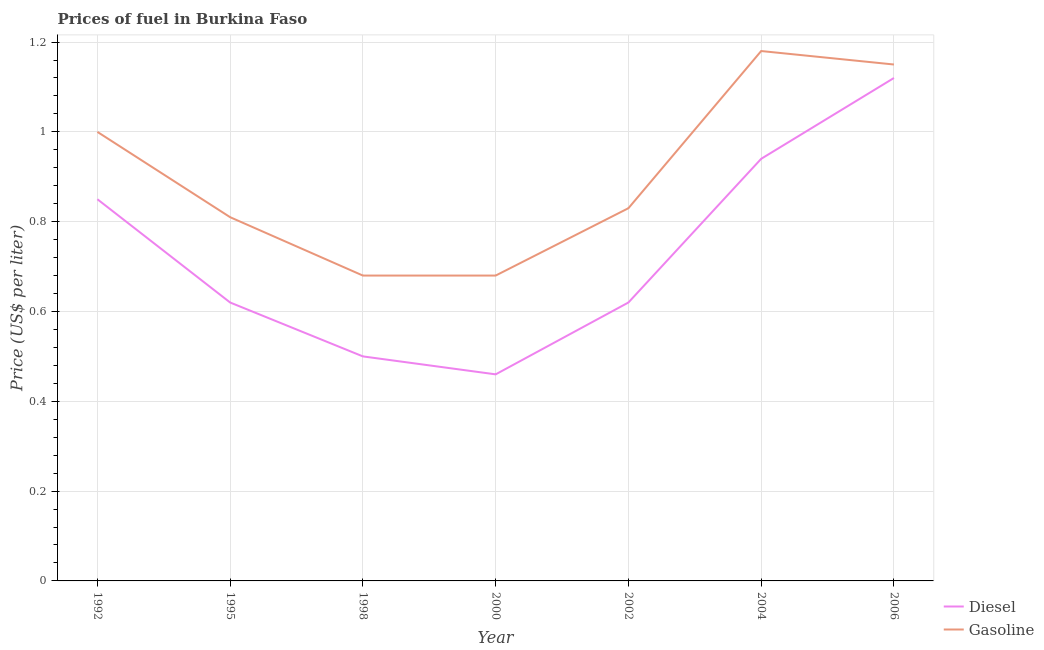How many different coloured lines are there?
Your answer should be very brief. 2. Does the line corresponding to diesel price intersect with the line corresponding to gasoline price?
Ensure brevity in your answer.  No. Is the number of lines equal to the number of legend labels?
Offer a very short reply. Yes. What is the gasoline price in 1995?
Offer a very short reply. 0.81. Across all years, what is the maximum gasoline price?
Provide a succinct answer. 1.18. Across all years, what is the minimum diesel price?
Provide a succinct answer. 0.46. In which year was the gasoline price maximum?
Provide a succinct answer. 2004. What is the total gasoline price in the graph?
Make the answer very short. 6.33. What is the difference between the diesel price in 1992 and that in 2004?
Ensure brevity in your answer.  -0.09. What is the difference between the diesel price in 1992 and the gasoline price in 1998?
Ensure brevity in your answer.  0.17. What is the average diesel price per year?
Make the answer very short. 0.73. In the year 2000, what is the difference between the gasoline price and diesel price?
Provide a short and direct response. 0.22. In how many years, is the gasoline price greater than 0.9600000000000001 US$ per litre?
Provide a succinct answer. 3. What is the ratio of the gasoline price in 1998 to that in 2004?
Your response must be concise. 0.58. Is the diesel price in 1998 less than that in 2004?
Keep it short and to the point. Yes. What is the difference between the highest and the second highest gasoline price?
Offer a terse response. 0.03. What is the difference between the highest and the lowest gasoline price?
Give a very brief answer. 0.5. In how many years, is the gasoline price greater than the average gasoline price taken over all years?
Provide a succinct answer. 3. Does the diesel price monotonically increase over the years?
Your answer should be compact. No. Is the diesel price strictly greater than the gasoline price over the years?
Offer a terse response. No. How many years are there in the graph?
Give a very brief answer. 7. Does the graph contain any zero values?
Your response must be concise. No. Where does the legend appear in the graph?
Ensure brevity in your answer.  Bottom right. How are the legend labels stacked?
Ensure brevity in your answer.  Vertical. What is the title of the graph?
Keep it short and to the point. Prices of fuel in Burkina Faso. What is the label or title of the X-axis?
Offer a very short reply. Year. What is the label or title of the Y-axis?
Provide a short and direct response. Price (US$ per liter). What is the Price (US$ per liter) in Diesel in 1992?
Make the answer very short. 0.85. What is the Price (US$ per liter) of Gasoline in 1992?
Make the answer very short. 1. What is the Price (US$ per liter) in Diesel in 1995?
Give a very brief answer. 0.62. What is the Price (US$ per liter) in Gasoline in 1995?
Your answer should be very brief. 0.81. What is the Price (US$ per liter) in Gasoline in 1998?
Ensure brevity in your answer.  0.68. What is the Price (US$ per liter) in Diesel in 2000?
Your answer should be very brief. 0.46. What is the Price (US$ per liter) in Gasoline in 2000?
Your answer should be compact. 0.68. What is the Price (US$ per liter) of Diesel in 2002?
Your answer should be compact. 0.62. What is the Price (US$ per liter) in Gasoline in 2002?
Ensure brevity in your answer.  0.83. What is the Price (US$ per liter) of Diesel in 2004?
Ensure brevity in your answer.  0.94. What is the Price (US$ per liter) of Gasoline in 2004?
Offer a very short reply. 1.18. What is the Price (US$ per liter) of Diesel in 2006?
Provide a succinct answer. 1.12. What is the Price (US$ per liter) of Gasoline in 2006?
Your answer should be compact. 1.15. Across all years, what is the maximum Price (US$ per liter) of Diesel?
Give a very brief answer. 1.12. Across all years, what is the maximum Price (US$ per liter) in Gasoline?
Provide a succinct answer. 1.18. Across all years, what is the minimum Price (US$ per liter) of Diesel?
Ensure brevity in your answer.  0.46. Across all years, what is the minimum Price (US$ per liter) in Gasoline?
Make the answer very short. 0.68. What is the total Price (US$ per liter) of Diesel in the graph?
Make the answer very short. 5.11. What is the total Price (US$ per liter) in Gasoline in the graph?
Ensure brevity in your answer.  6.33. What is the difference between the Price (US$ per liter) of Diesel in 1992 and that in 1995?
Your response must be concise. 0.23. What is the difference between the Price (US$ per liter) in Gasoline in 1992 and that in 1995?
Provide a short and direct response. 0.19. What is the difference between the Price (US$ per liter) of Gasoline in 1992 and that in 1998?
Your response must be concise. 0.32. What is the difference between the Price (US$ per liter) in Diesel in 1992 and that in 2000?
Your answer should be compact. 0.39. What is the difference between the Price (US$ per liter) of Gasoline in 1992 and that in 2000?
Make the answer very short. 0.32. What is the difference between the Price (US$ per liter) in Diesel in 1992 and that in 2002?
Offer a terse response. 0.23. What is the difference between the Price (US$ per liter) of Gasoline in 1992 and that in 2002?
Your response must be concise. 0.17. What is the difference between the Price (US$ per liter) of Diesel in 1992 and that in 2004?
Keep it short and to the point. -0.09. What is the difference between the Price (US$ per liter) in Gasoline in 1992 and that in 2004?
Ensure brevity in your answer.  -0.18. What is the difference between the Price (US$ per liter) of Diesel in 1992 and that in 2006?
Your answer should be compact. -0.27. What is the difference between the Price (US$ per liter) of Gasoline in 1992 and that in 2006?
Your response must be concise. -0.15. What is the difference between the Price (US$ per liter) in Diesel in 1995 and that in 1998?
Give a very brief answer. 0.12. What is the difference between the Price (US$ per liter) of Gasoline in 1995 and that in 1998?
Your response must be concise. 0.13. What is the difference between the Price (US$ per liter) of Diesel in 1995 and that in 2000?
Your answer should be very brief. 0.16. What is the difference between the Price (US$ per liter) in Gasoline in 1995 and that in 2000?
Make the answer very short. 0.13. What is the difference between the Price (US$ per liter) in Gasoline in 1995 and that in 2002?
Provide a short and direct response. -0.02. What is the difference between the Price (US$ per liter) of Diesel in 1995 and that in 2004?
Make the answer very short. -0.32. What is the difference between the Price (US$ per liter) in Gasoline in 1995 and that in 2004?
Your answer should be compact. -0.37. What is the difference between the Price (US$ per liter) in Diesel in 1995 and that in 2006?
Keep it short and to the point. -0.5. What is the difference between the Price (US$ per liter) of Gasoline in 1995 and that in 2006?
Your answer should be compact. -0.34. What is the difference between the Price (US$ per liter) of Diesel in 1998 and that in 2000?
Keep it short and to the point. 0.04. What is the difference between the Price (US$ per liter) of Gasoline in 1998 and that in 2000?
Provide a short and direct response. 0. What is the difference between the Price (US$ per liter) in Diesel in 1998 and that in 2002?
Give a very brief answer. -0.12. What is the difference between the Price (US$ per liter) of Diesel in 1998 and that in 2004?
Keep it short and to the point. -0.44. What is the difference between the Price (US$ per liter) of Gasoline in 1998 and that in 2004?
Offer a terse response. -0.5. What is the difference between the Price (US$ per liter) of Diesel in 1998 and that in 2006?
Offer a terse response. -0.62. What is the difference between the Price (US$ per liter) in Gasoline in 1998 and that in 2006?
Provide a short and direct response. -0.47. What is the difference between the Price (US$ per liter) in Diesel in 2000 and that in 2002?
Offer a terse response. -0.16. What is the difference between the Price (US$ per liter) of Gasoline in 2000 and that in 2002?
Provide a short and direct response. -0.15. What is the difference between the Price (US$ per liter) in Diesel in 2000 and that in 2004?
Ensure brevity in your answer.  -0.48. What is the difference between the Price (US$ per liter) in Diesel in 2000 and that in 2006?
Keep it short and to the point. -0.66. What is the difference between the Price (US$ per liter) of Gasoline in 2000 and that in 2006?
Offer a very short reply. -0.47. What is the difference between the Price (US$ per liter) in Diesel in 2002 and that in 2004?
Offer a very short reply. -0.32. What is the difference between the Price (US$ per liter) in Gasoline in 2002 and that in 2004?
Provide a short and direct response. -0.35. What is the difference between the Price (US$ per liter) in Diesel in 2002 and that in 2006?
Ensure brevity in your answer.  -0.5. What is the difference between the Price (US$ per liter) in Gasoline in 2002 and that in 2006?
Your answer should be compact. -0.32. What is the difference between the Price (US$ per liter) of Diesel in 2004 and that in 2006?
Provide a succinct answer. -0.18. What is the difference between the Price (US$ per liter) in Diesel in 1992 and the Price (US$ per liter) in Gasoline in 1998?
Your response must be concise. 0.17. What is the difference between the Price (US$ per liter) of Diesel in 1992 and the Price (US$ per liter) of Gasoline in 2000?
Keep it short and to the point. 0.17. What is the difference between the Price (US$ per liter) in Diesel in 1992 and the Price (US$ per liter) in Gasoline in 2002?
Keep it short and to the point. 0.02. What is the difference between the Price (US$ per liter) of Diesel in 1992 and the Price (US$ per liter) of Gasoline in 2004?
Offer a very short reply. -0.33. What is the difference between the Price (US$ per liter) in Diesel in 1995 and the Price (US$ per liter) in Gasoline in 1998?
Provide a short and direct response. -0.06. What is the difference between the Price (US$ per liter) of Diesel in 1995 and the Price (US$ per liter) of Gasoline in 2000?
Provide a short and direct response. -0.06. What is the difference between the Price (US$ per liter) of Diesel in 1995 and the Price (US$ per liter) of Gasoline in 2002?
Keep it short and to the point. -0.21. What is the difference between the Price (US$ per liter) in Diesel in 1995 and the Price (US$ per liter) in Gasoline in 2004?
Make the answer very short. -0.56. What is the difference between the Price (US$ per liter) of Diesel in 1995 and the Price (US$ per liter) of Gasoline in 2006?
Provide a short and direct response. -0.53. What is the difference between the Price (US$ per liter) in Diesel in 1998 and the Price (US$ per liter) in Gasoline in 2000?
Offer a terse response. -0.18. What is the difference between the Price (US$ per liter) in Diesel in 1998 and the Price (US$ per liter) in Gasoline in 2002?
Provide a succinct answer. -0.33. What is the difference between the Price (US$ per liter) of Diesel in 1998 and the Price (US$ per liter) of Gasoline in 2004?
Offer a very short reply. -0.68. What is the difference between the Price (US$ per liter) of Diesel in 1998 and the Price (US$ per liter) of Gasoline in 2006?
Offer a terse response. -0.65. What is the difference between the Price (US$ per liter) of Diesel in 2000 and the Price (US$ per liter) of Gasoline in 2002?
Your response must be concise. -0.37. What is the difference between the Price (US$ per liter) in Diesel in 2000 and the Price (US$ per liter) in Gasoline in 2004?
Provide a short and direct response. -0.72. What is the difference between the Price (US$ per liter) in Diesel in 2000 and the Price (US$ per liter) in Gasoline in 2006?
Ensure brevity in your answer.  -0.69. What is the difference between the Price (US$ per liter) of Diesel in 2002 and the Price (US$ per liter) of Gasoline in 2004?
Provide a succinct answer. -0.56. What is the difference between the Price (US$ per liter) in Diesel in 2002 and the Price (US$ per liter) in Gasoline in 2006?
Your response must be concise. -0.53. What is the difference between the Price (US$ per liter) of Diesel in 2004 and the Price (US$ per liter) of Gasoline in 2006?
Provide a succinct answer. -0.21. What is the average Price (US$ per liter) in Diesel per year?
Ensure brevity in your answer.  0.73. What is the average Price (US$ per liter) of Gasoline per year?
Give a very brief answer. 0.9. In the year 1992, what is the difference between the Price (US$ per liter) in Diesel and Price (US$ per liter) in Gasoline?
Give a very brief answer. -0.15. In the year 1995, what is the difference between the Price (US$ per liter) of Diesel and Price (US$ per liter) of Gasoline?
Give a very brief answer. -0.19. In the year 1998, what is the difference between the Price (US$ per liter) in Diesel and Price (US$ per liter) in Gasoline?
Offer a terse response. -0.18. In the year 2000, what is the difference between the Price (US$ per liter) of Diesel and Price (US$ per liter) of Gasoline?
Offer a terse response. -0.22. In the year 2002, what is the difference between the Price (US$ per liter) in Diesel and Price (US$ per liter) in Gasoline?
Provide a short and direct response. -0.21. In the year 2004, what is the difference between the Price (US$ per liter) of Diesel and Price (US$ per liter) of Gasoline?
Provide a short and direct response. -0.24. In the year 2006, what is the difference between the Price (US$ per liter) in Diesel and Price (US$ per liter) in Gasoline?
Your response must be concise. -0.03. What is the ratio of the Price (US$ per liter) of Diesel in 1992 to that in 1995?
Your answer should be compact. 1.37. What is the ratio of the Price (US$ per liter) of Gasoline in 1992 to that in 1995?
Provide a short and direct response. 1.23. What is the ratio of the Price (US$ per liter) of Diesel in 1992 to that in 1998?
Give a very brief answer. 1.7. What is the ratio of the Price (US$ per liter) in Gasoline in 1992 to that in 1998?
Your response must be concise. 1.47. What is the ratio of the Price (US$ per liter) in Diesel in 1992 to that in 2000?
Offer a very short reply. 1.85. What is the ratio of the Price (US$ per liter) of Gasoline in 1992 to that in 2000?
Your response must be concise. 1.47. What is the ratio of the Price (US$ per liter) of Diesel in 1992 to that in 2002?
Make the answer very short. 1.37. What is the ratio of the Price (US$ per liter) of Gasoline in 1992 to that in 2002?
Your answer should be very brief. 1.2. What is the ratio of the Price (US$ per liter) in Diesel in 1992 to that in 2004?
Provide a short and direct response. 0.9. What is the ratio of the Price (US$ per liter) in Gasoline in 1992 to that in 2004?
Your answer should be compact. 0.85. What is the ratio of the Price (US$ per liter) in Diesel in 1992 to that in 2006?
Give a very brief answer. 0.76. What is the ratio of the Price (US$ per liter) of Gasoline in 1992 to that in 2006?
Provide a succinct answer. 0.87. What is the ratio of the Price (US$ per liter) in Diesel in 1995 to that in 1998?
Give a very brief answer. 1.24. What is the ratio of the Price (US$ per liter) of Gasoline in 1995 to that in 1998?
Keep it short and to the point. 1.19. What is the ratio of the Price (US$ per liter) of Diesel in 1995 to that in 2000?
Make the answer very short. 1.35. What is the ratio of the Price (US$ per liter) in Gasoline in 1995 to that in 2000?
Offer a terse response. 1.19. What is the ratio of the Price (US$ per liter) in Gasoline in 1995 to that in 2002?
Give a very brief answer. 0.98. What is the ratio of the Price (US$ per liter) in Diesel in 1995 to that in 2004?
Ensure brevity in your answer.  0.66. What is the ratio of the Price (US$ per liter) in Gasoline in 1995 to that in 2004?
Provide a succinct answer. 0.69. What is the ratio of the Price (US$ per liter) in Diesel in 1995 to that in 2006?
Your answer should be very brief. 0.55. What is the ratio of the Price (US$ per liter) of Gasoline in 1995 to that in 2006?
Give a very brief answer. 0.7. What is the ratio of the Price (US$ per liter) of Diesel in 1998 to that in 2000?
Offer a very short reply. 1.09. What is the ratio of the Price (US$ per liter) of Gasoline in 1998 to that in 2000?
Keep it short and to the point. 1. What is the ratio of the Price (US$ per liter) of Diesel in 1998 to that in 2002?
Keep it short and to the point. 0.81. What is the ratio of the Price (US$ per liter) of Gasoline in 1998 to that in 2002?
Keep it short and to the point. 0.82. What is the ratio of the Price (US$ per liter) in Diesel in 1998 to that in 2004?
Give a very brief answer. 0.53. What is the ratio of the Price (US$ per liter) of Gasoline in 1998 to that in 2004?
Give a very brief answer. 0.58. What is the ratio of the Price (US$ per liter) in Diesel in 1998 to that in 2006?
Provide a succinct answer. 0.45. What is the ratio of the Price (US$ per liter) in Gasoline in 1998 to that in 2006?
Keep it short and to the point. 0.59. What is the ratio of the Price (US$ per liter) of Diesel in 2000 to that in 2002?
Provide a succinct answer. 0.74. What is the ratio of the Price (US$ per liter) in Gasoline in 2000 to that in 2002?
Provide a succinct answer. 0.82. What is the ratio of the Price (US$ per liter) in Diesel in 2000 to that in 2004?
Keep it short and to the point. 0.49. What is the ratio of the Price (US$ per liter) in Gasoline in 2000 to that in 2004?
Provide a succinct answer. 0.58. What is the ratio of the Price (US$ per liter) in Diesel in 2000 to that in 2006?
Your answer should be compact. 0.41. What is the ratio of the Price (US$ per liter) in Gasoline in 2000 to that in 2006?
Keep it short and to the point. 0.59. What is the ratio of the Price (US$ per liter) of Diesel in 2002 to that in 2004?
Ensure brevity in your answer.  0.66. What is the ratio of the Price (US$ per liter) of Gasoline in 2002 to that in 2004?
Ensure brevity in your answer.  0.7. What is the ratio of the Price (US$ per liter) of Diesel in 2002 to that in 2006?
Ensure brevity in your answer.  0.55. What is the ratio of the Price (US$ per liter) in Gasoline in 2002 to that in 2006?
Your response must be concise. 0.72. What is the ratio of the Price (US$ per liter) of Diesel in 2004 to that in 2006?
Provide a short and direct response. 0.84. What is the ratio of the Price (US$ per liter) of Gasoline in 2004 to that in 2006?
Give a very brief answer. 1.03. What is the difference between the highest and the second highest Price (US$ per liter) in Diesel?
Provide a short and direct response. 0.18. What is the difference between the highest and the lowest Price (US$ per liter) in Diesel?
Keep it short and to the point. 0.66. What is the difference between the highest and the lowest Price (US$ per liter) of Gasoline?
Make the answer very short. 0.5. 